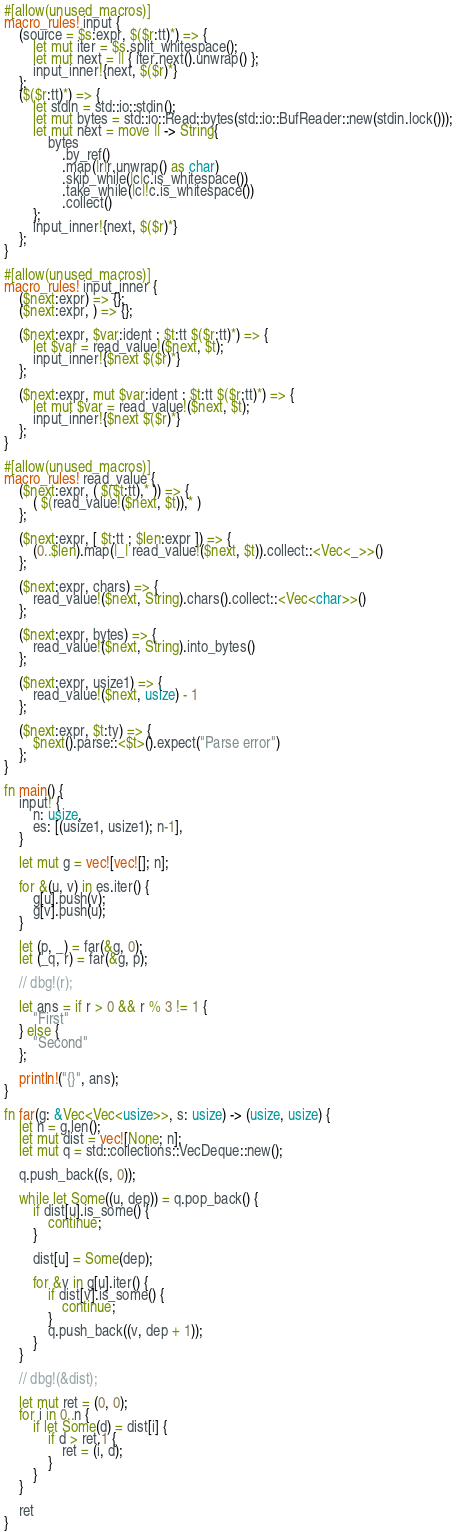Convert code to text. <code><loc_0><loc_0><loc_500><loc_500><_Rust_>#[allow(unused_macros)]
macro_rules! input {
    (source = $s:expr, $($r:tt)*) => {
        let mut iter = $s.split_whitespace();
        let mut next = || { iter.next().unwrap() };
        input_inner!{next, $($r)*}
    };
    ($($r:tt)*) => {
        let stdin = std::io::stdin();
        let mut bytes = std::io::Read::bytes(std::io::BufReader::new(stdin.lock()));
        let mut next = move || -> String{
            bytes
                .by_ref()
                .map(|r|r.unwrap() as char)
                .skip_while(|c|c.is_whitespace())
                .take_while(|c|!c.is_whitespace())
                .collect()
        };
        input_inner!{next, $($r)*}
    };
}

#[allow(unused_macros)]
macro_rules! input_inner {
    ($next:expr) => {};
    ($next:expr, ) => {};

    ($next:expr, $var:ident : $t:tt $($r:tt)*) => {
        let $var = read_value!($next, $t);
        input_inner!{$next $($r)*}
    };

    ($next:expr, mut $var:ident : $t:tt $($r:tt)*) => {
        let mut $var = read_value!($next, $t);
        input_inner!{$next $($r)*}
    };
}

#[allow(unused_macros)]
macro_rules! read_value {
    ($next:expr, ( $($t:tt),* )) => {
        ( $(read_value!($next, $t)),* )
    };

    ($next:expr, [ $t:tt ; $len:expr ]) => {
        (0..$len).map(|_| read_value!($next, $t)).collect::<Vec<_>>()
    };

    ($next:expr, chars) => {
        read_value!($next, String).chars().collect::<Vec<char>>()
    };

    ($next:expr, bytes) => {
        read_value!($next, String).into_bytes()
    };

    ($next:expr, usize1) => {
        read_value!($next, usize) - 1
    };

    ($next:expr, $t:ty) => {
        $next().parse::<$t>().expect("Parse error")
    };
}

fn main() {
    input! {
        n: usize,
        es: [(usize1, usize1); n-1],
    }

    let mut g = vec![vec![]; n];

    for &(u, v) in es.iter() {
        g[u].push(v);
        g[v].push(u);
    }

    let (p, _) = far(&g, 0);
    let (_q, r) = far(&g, p);

    // dbg!(r);

    let ans = if r > 0 && r % 3 != 1 {
        "First"
    } else {
        "Second"
    };

    println!("{}", ans);
}

fn far(g: &Vec<Vec<usize>>, s: usize) -> (usize, usize) {
    let n = g.len();
    let mut dist = vec![None; n];
    let mut q = std::collections::VecDeque::new();

    q.push_back((s, 0));

    while let Some((u, dep)) = q.pop_back() {
        if dist[u].is_some() {
            continue;
        }

        dist[u] = Some(dep);

        for &v in g[u].iter() {
            if dist[v].is_some() {
                continue;
            }
            q.push_back((v, dep + 1));
        }
    }

    // dbg!(&dist);

    let mut ret = (0, 0);
    for i in 0..n {
        if let Some(d) = dist[i] {
            if d > ret.1 {
                ret = (i, d);
            }
        }
    }

    ret
}
</code> 